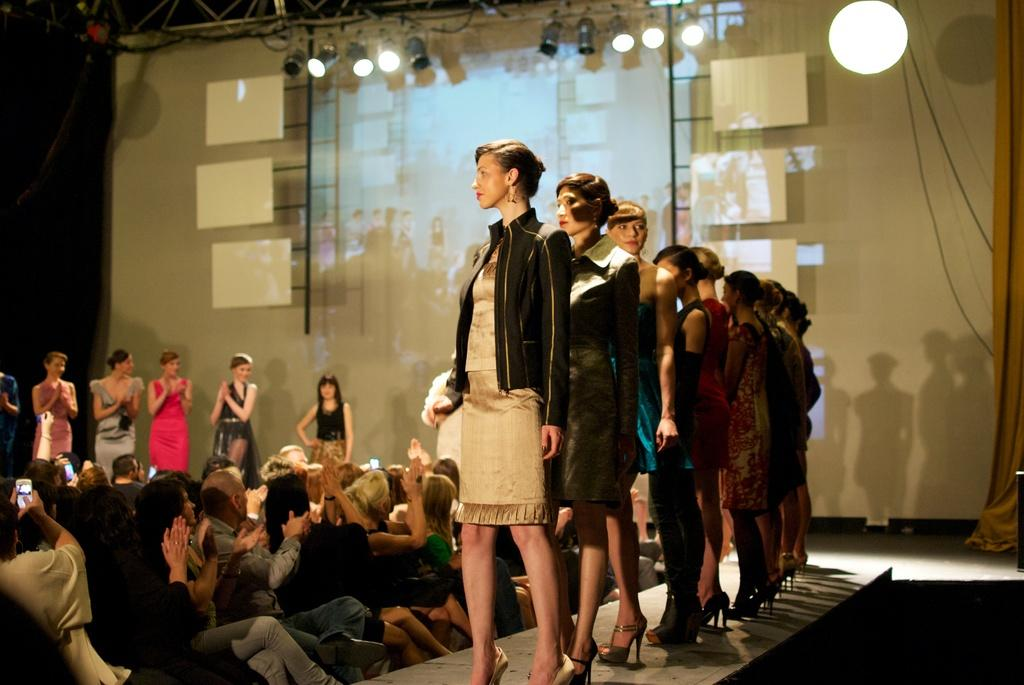Who is present in the image? There are ladies in the image. What are the ladies doing in the image? The ladies are standing on a ramp. Are there any other people in the image besides the ladies? Yes, there are other people sitting in the image. What can be seen on the roof in the image? There are lights on the roof in the image. Can you see any stars in the image? There are no stars visible in the image. Is there any blood present in the image? There is no blood present in the image. 